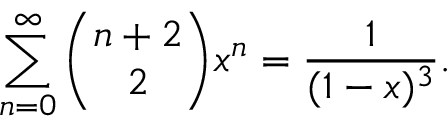<formula> <loc_0><loc_0><loc_500><loc_500>\sum _ { n = 0 } ^ { \infty } { \binom { n + 2 } { 2 } } x ^ { n } = { \frac { 1 } { ( 1 - x ) ^ { 3 } } } .</formula> 